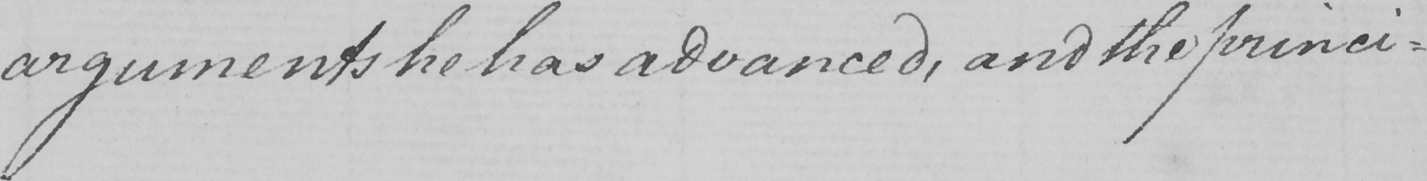Can you tell me what this handwritten text says? arguments he has advanced , and the princi- 